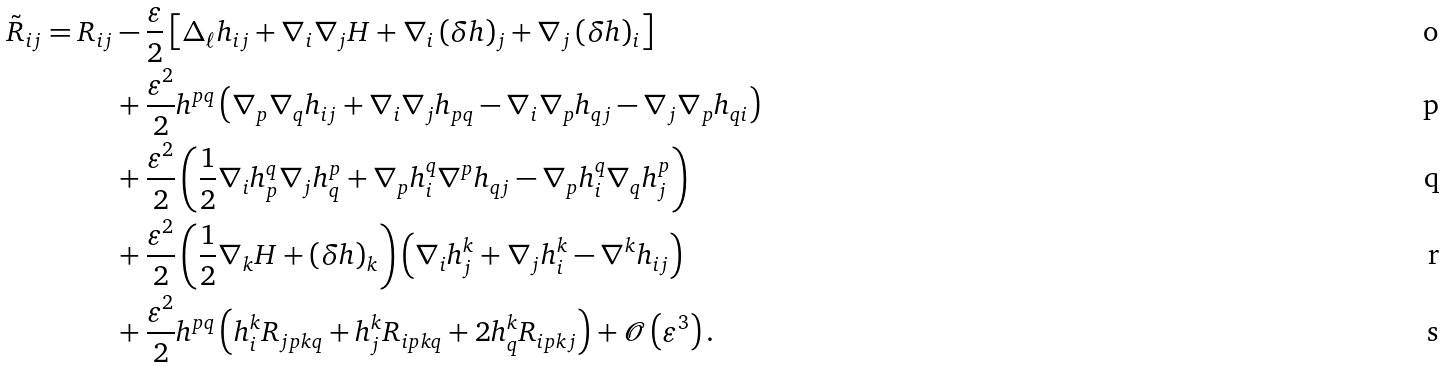Convert formula to latex. <formula><loc_0><loc_0><loc_500><loc_500>\tilde { R } _ { i j } = R _ { i j } & - \frac { \varepsilon } { 2 } \left [ \Delta _ { \ell } h _ { i j } + \nabla _ { i } \nabla _ { j } H + \nabla _ { i } \left ( \delta h \right ) _ { j } + \nabla _ { j } \left ( \delta h \right ) _ { i } \right ] \\ & + \frac { \varepsilon ^ { 2 } } { 2 } h ^ { p q } \left ( \nabla _ { p } \nabla _ { q } h _ { i j } + \nabla _ { i } \nabla _ { j } h _ { p q } - \nabla _ { i } \nabla _ { p } h _ { q j } - \nabla _ { j } \nabla _ { p } h _ { q i } \right ) \\ & + \frac { \varepsilon ^ { 2 } } { 2 } \left ( \frac { 1 } { 2 } \nabla _ { i } h _ { p } ^ { q } \nabla _ { j } h _ { q } ^ { p } + \nabla _ { p } h _ { i } ^ { q } \nabla ^ { p } h _ { q j } - \nabla _ { p } h _ { i } ^ { q } \nabla _ { q } h _ { j } ^ { p } \right ) \\ & + \frac { \varepsilon ^ { 2 } } { 2 } \left ( \frac { 1 } { 2 } \nabla _ { k } H + \left ( \delta h \right ) _ { k } \right ) \left ( \nabla _ { i } h _ { j } ^ { k } + \nabla _ { j } h _ { i } ^ { k } - \nabla ^ { k } h _ { i j } \right ) \\ & + \frac { \varepsilon ^ { 2 } } { 2 } h ^ { p q } \left ( h _ { i } ^ { k } R _ { j p k q } + h _ { j } ^ { k } R _ { i p k q } + 2 h _ { q } ^ { k } R _ { i p k j } \right ) + \mathcal { O } \left ( \varepsilon ^ { 3 } \right ) .</formula> 